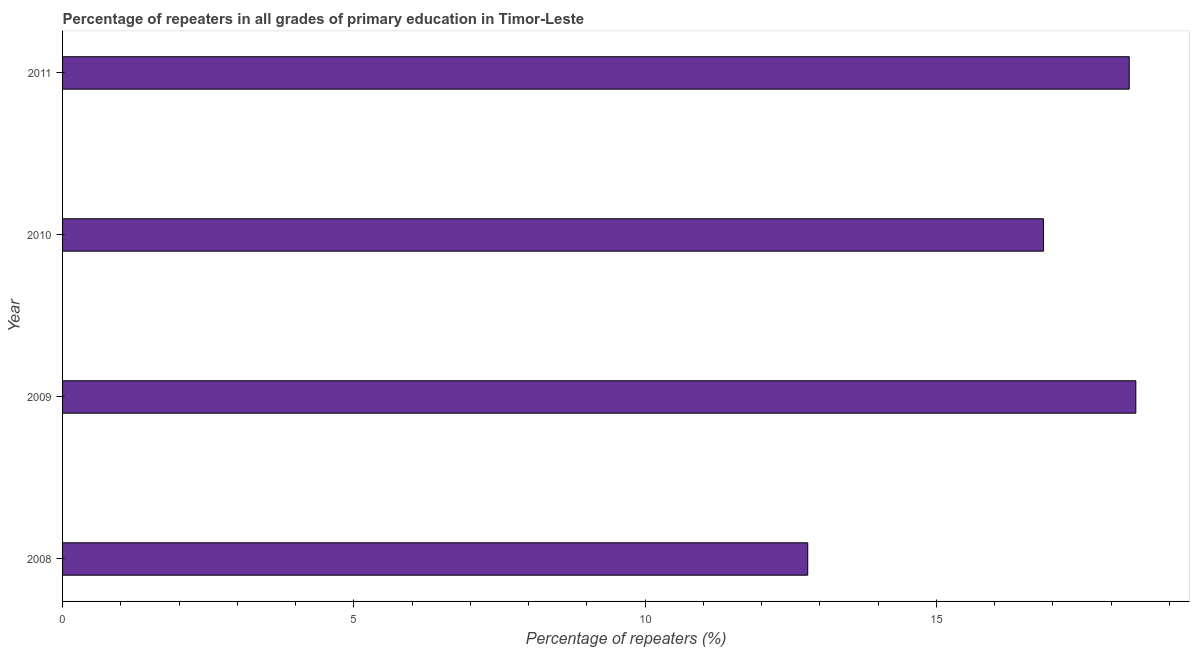What is the title of the graph?
Make the answer very short. Percentage of repeaters in all grades of primary education in Timor-Leste. What is the label or title of the X-axis?
Provide a succinct answer. Percentage of repeaters (%). What is the percentage of repeaters in primary education in 2011?
Your answer should be very brief. 18.31. Across all years, what is the maximum percentage of repeaters in primary education?
Your response must be concise. 18.42. Across all years, what is the minimum percentage of repeaters in primary education?
Make the answer very short. 12.79. In which year was the percentage of repeaters in primary education maximum?
Provide a succinct answer. 2009. What is the sum of the percentage of repeaters in primary education?
Your answer should be compact. 66.37. What is the difference between the percentage of repeaters in primary education in 2008 and 2011?
Your answer should be very brief. -5.52. What is the average percentage of repeaters in primary education per year?
Keep it short and to the point. 16.59. What is the median percentage of repeaters in primary education?
Your answer should be very brief. 17.57. In how many years, is the percentage of repeaters in primary education greater than 15 %?
Provide a succinct answer. 3. What is the ratio of the percentage of repeaters in primary education in 2009 to that in 2010?
Your answer should be very brief. 1.09. Is the difference between the percentage of repeaters in primary education in 2010 and 2011 greater than the difference between any two years?
Your answer should be compact. No. What is the difference between the highest and the second highest percentage of repeaters in primary education?
Keep it short and to the point. 0.11. Is the sum of the percentage of repeaters in primary education in 2009 and 2010 greater than the maximum percentage of repeaters in primary education across all years?
Your response must be concise. Yes. What is the difference between the highest and the lowest percentage of repeaters in primary education?
Your answer should be compact. 5.63. In how many years, is the percentage of repeaters in primary education greater than the average percentage of repeaters in primary education taken over all years?
Offer a terse response. 3. Are all the bars in the graph horizontal?
Provide a short and direct response. Yes. Are the values on the major ticks of X-axis written in scientific E-notation?
Offer a terse response. No. What is the Percentage of repeaters (%) of 2008?
Your response must be concise. 12.79. What is the Percentage of repeaters (%) in 2009?
Ensure brevity in your answer.  18.42. What is the Percentage of repeaters (%) in 2010?
Your answer should be compact. 16.84. What is the Percentage of repeaters (%) in 2011?
Offer a terse response. 18.31. What is the difference between the Percentage of repeaters (%) in 2008 and 2009?
Your response must be concise. -5.63. What is the difference between the Percentage of repeaters (%) in 2008 and 2010?
Keep it short and to the point. -4.05. What is the difference between the Percentage of repeaters (%) in 2008 and 2011?
Make the answer very short. -5.52. What is the difference between the Percentage of repeaters (%) in 2009 and 2010?
Offer a terse response. 1.59. What is the difference between the Percentage of repeaters (%) in 2009 and 2011?
Give a very brief answer. 0.11. What is the difference between the Percentage of repeaters (%) in 2010 and 2011?
Your answer should be very brief. -1.47. What is the ratio of the Percentage of repeaters (%) in 2008 to that in 2009?
Make the answer very short. 0.69. What is the ratio of the Percentage of repeaters (%) in 2008 to that in 2010?
Your response must be concise. 0.76. What is the ratio of the Percentage of repeaters (%) in 2008 to that in 2011?
Offer a very short reply. 0.7. What is the ratio of the Percentage of repeaters (%) in 2009 to that in 2010?
Your response must be concise. 1.09. What is the ratio of the Percentage of repeaters (%) in 2010 to that in 2011?
Your answer should be compact. 0.92. 